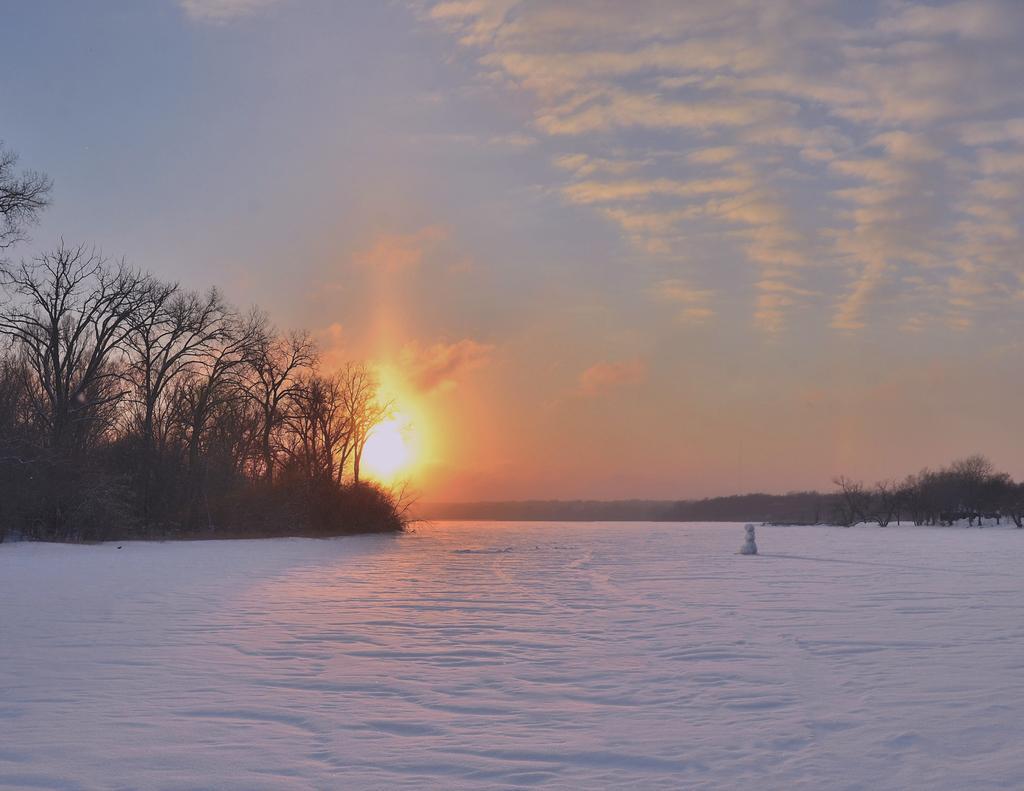In one or two sentences, can you explain what this image depicts? In this image we can see a snowman placed on the ground which is covered with snow. We can also see a group of trees, the hills, the sun and the sky which looks cloudy. 